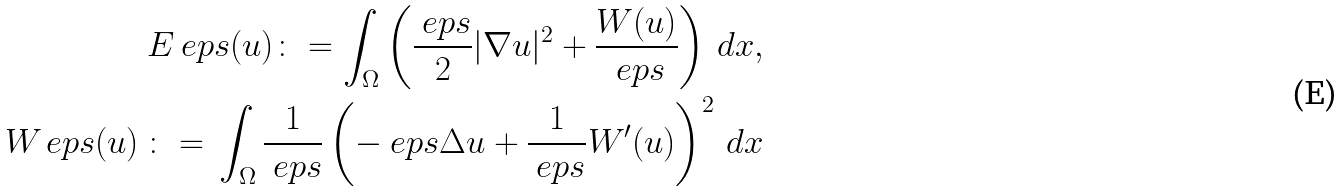<formula> <loc_0><loc_0><loc_500><loc_500>E _ { \ } e p s ( u ) \colon = \int _ { \Omega } \left ( \frac { \ e p s } { 2 } | \nabla u | ^ { 2 } + \frac { W ( u ) } { \ e p s } \right ) \, d x , \\ \ W _ { \ } e p s ( u ) \, \colon = \, \int _ { \Omega } \frac { 1 } { \ e p s } \left ( - \ e p s \Delta u + \frac { 1 } { \ e p s } W ^ { \prime } ( u ) \right ) ^ { 2 } \, d x</formula> 